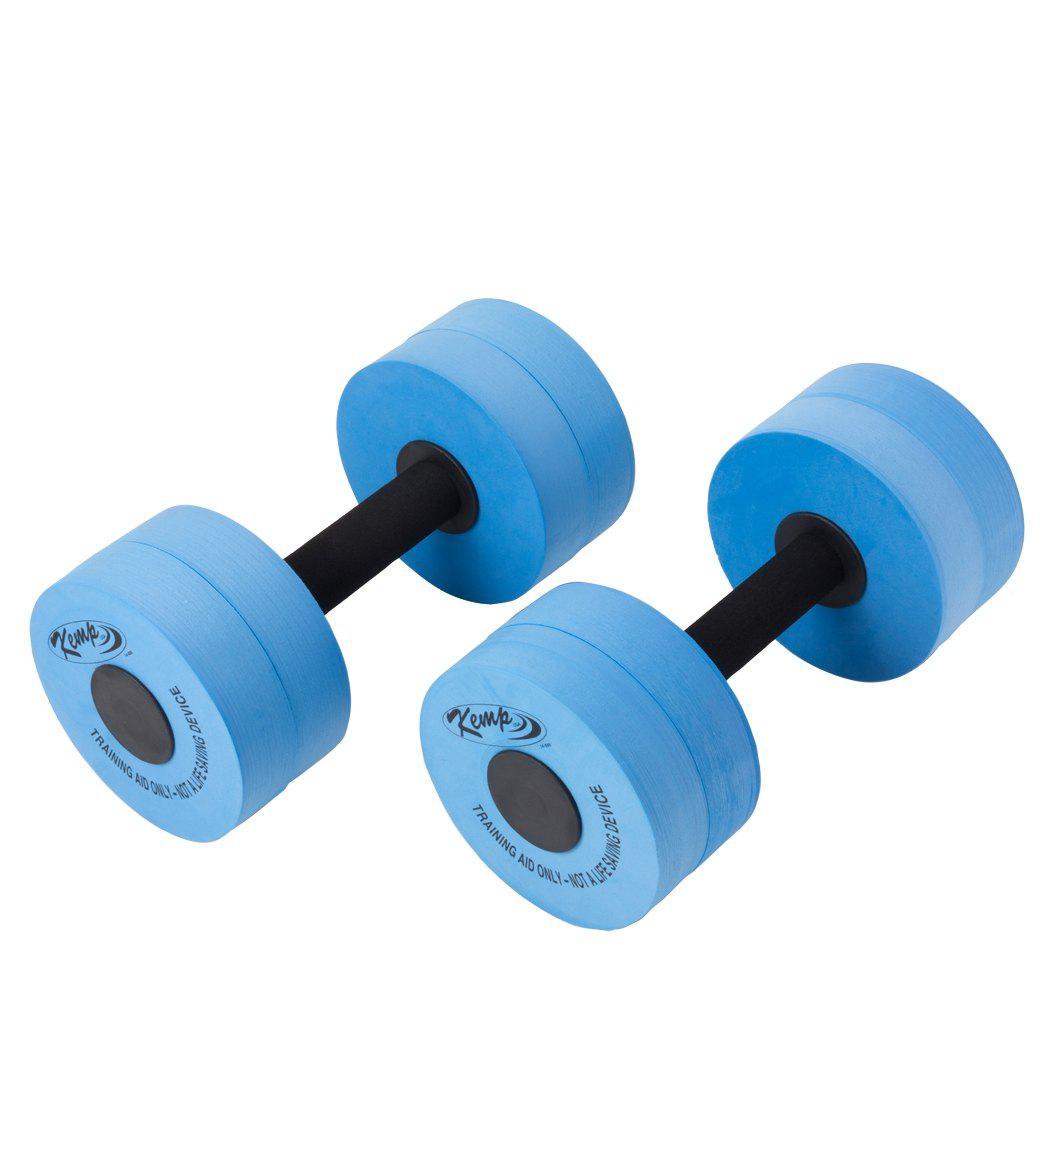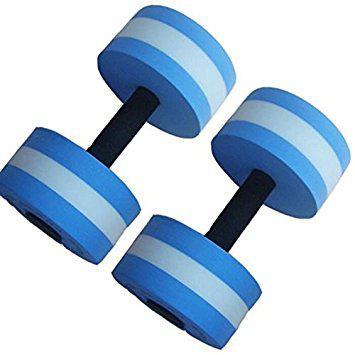The first image is the image on the left, the second image is the image on the right. Examine the images to the left and right. Is the description "There are four blue water dumbbell with only two that have white stripes on it." accurate? Answer yes or no. Yes. The first image is the image on the left, the second image is the image on the right. For the images shown, is this caption "Four or fewer dumb bells are visible." true? Answer yes or no. Yes. 